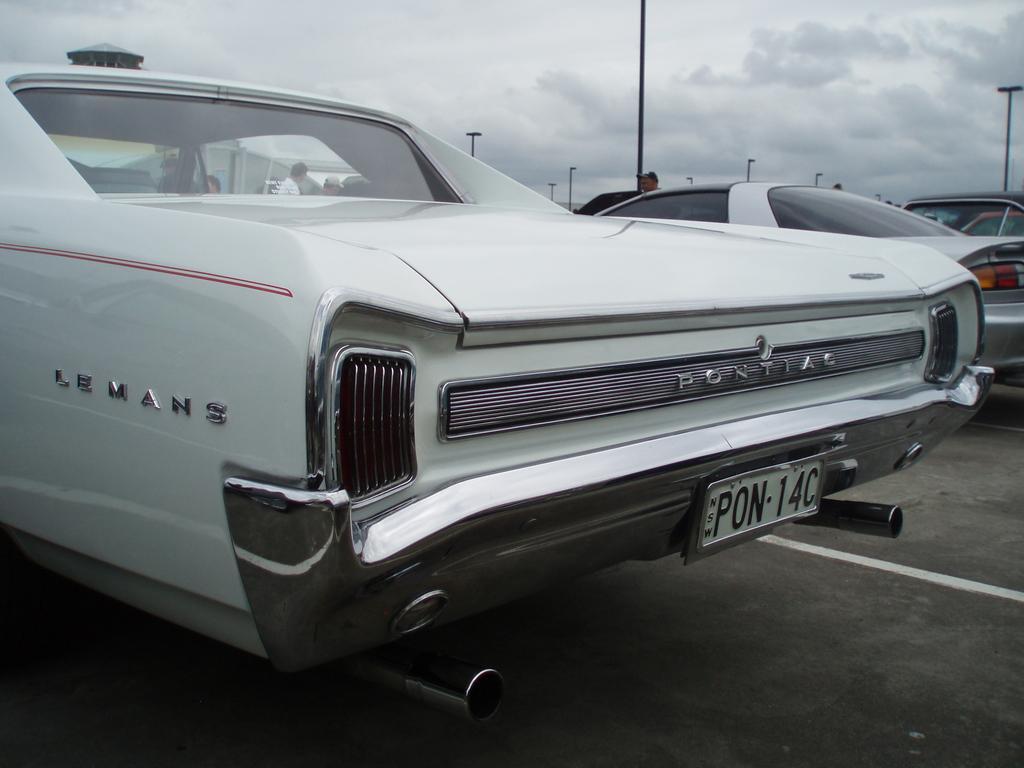Please provide a concise description of this image. This image is clicked outside. There are cars in the middle. There are poles in the middle. There is sky at the top. 